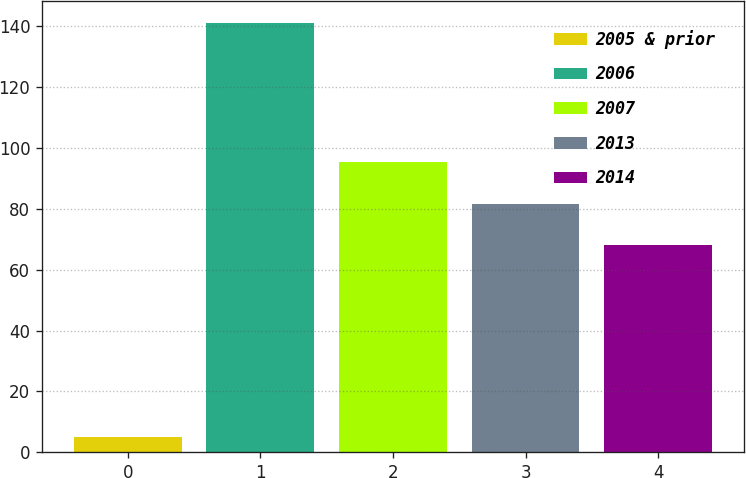Convert chart. <chart><loc_0><loc_0><loc_500><loc_500><bar_chart><fcel>2005 & prior<fcel>2006<fcel>2007<fcel>2013<fcel>2014<nl><fcel>5<fcel>141<fcel>95.2<fcel>81.6<fcel>68<nl></chart> 